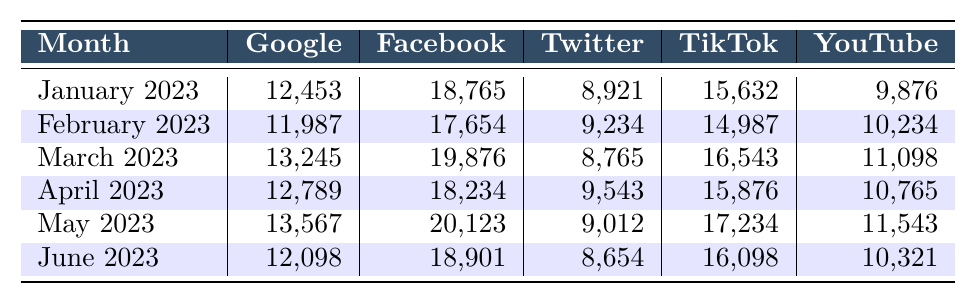What was the highest content removal request for Google? Looking at the data for Google, the highest number of removal requests is in March 2023, with a total of 13,245 requests.
Answer: 13,245 Which month saw the lowest content removal requests on Twitter? By checking the Twitter column, June 2023 has the lowest number of removal requests at 8,654.
Answer: 8,654 What is the total number of content removal requests for TikTok across all months? Summing the TikTok requests: 15,632 + 14,987 + 16,543 + 15,876 + 17,234 + 16,098 = 96,370.
Answer: 96,370 Did Facebook have consistently increasing requests every month? The data shows fluctuations in the number of requests; it increased from January to May but then decreased in June, indicating they were not consistently increasing.
Answer: No What was the average number of content removal requests for YouTube from January to June? Adding YouTube requests: 9,876 + 10,234 + 11,098 + 10,765 + 11,543 + 10,321 = 63,837. Dividing by 6 gives an average of 10,639.5.
Answer: 10,639.5 In which month did TikTok have the most removal requests compared to YouTube? By comparing the counts for each month, TikTok's highest request was in May 2023 with 17,234, while YouTube had 11,543 in the same month, making it the month where TikTok surpassed YouTube.
Answer: May 2023 What percentage of the total removal requests for Google in May 2023 does it represent compared to its highest month? In May 2023, Google had 13,567 requests, and its highest was 13,245 in March 2023. To find the percentage: (13,567 / 13,245) * 100 = 102.43%.
Answer: 102.43% Which platform had the highest number of removal requests in February 2023? In February 2023, Facebook had the highest number of removal requests with 17,654 compared to others.
Answer: Facebook How many more removal requests did Facebook have compared to Twitter in March 2023? In March 2023, Facebook had 19,876 requests, while Twitter had 8,765. The difference is 19,876 - 8,765 = 11,111.
Answer: 11,111 What is the overall trend in content removal requests for Google from January to June 2023? The data shows a small increase in requests in the early months, with a peak in March followed by a gradual decline in April, a slight increase in May, and then another decrease in June.
Answer: Fluctuating Which month recorded the second-highest number of removal requests for Facebook? Analyzing the Facebook requests, May 2023 has the second-highest requests at 20,123, while March 2023 has the highest with 19,876.
Answer: May 2023 